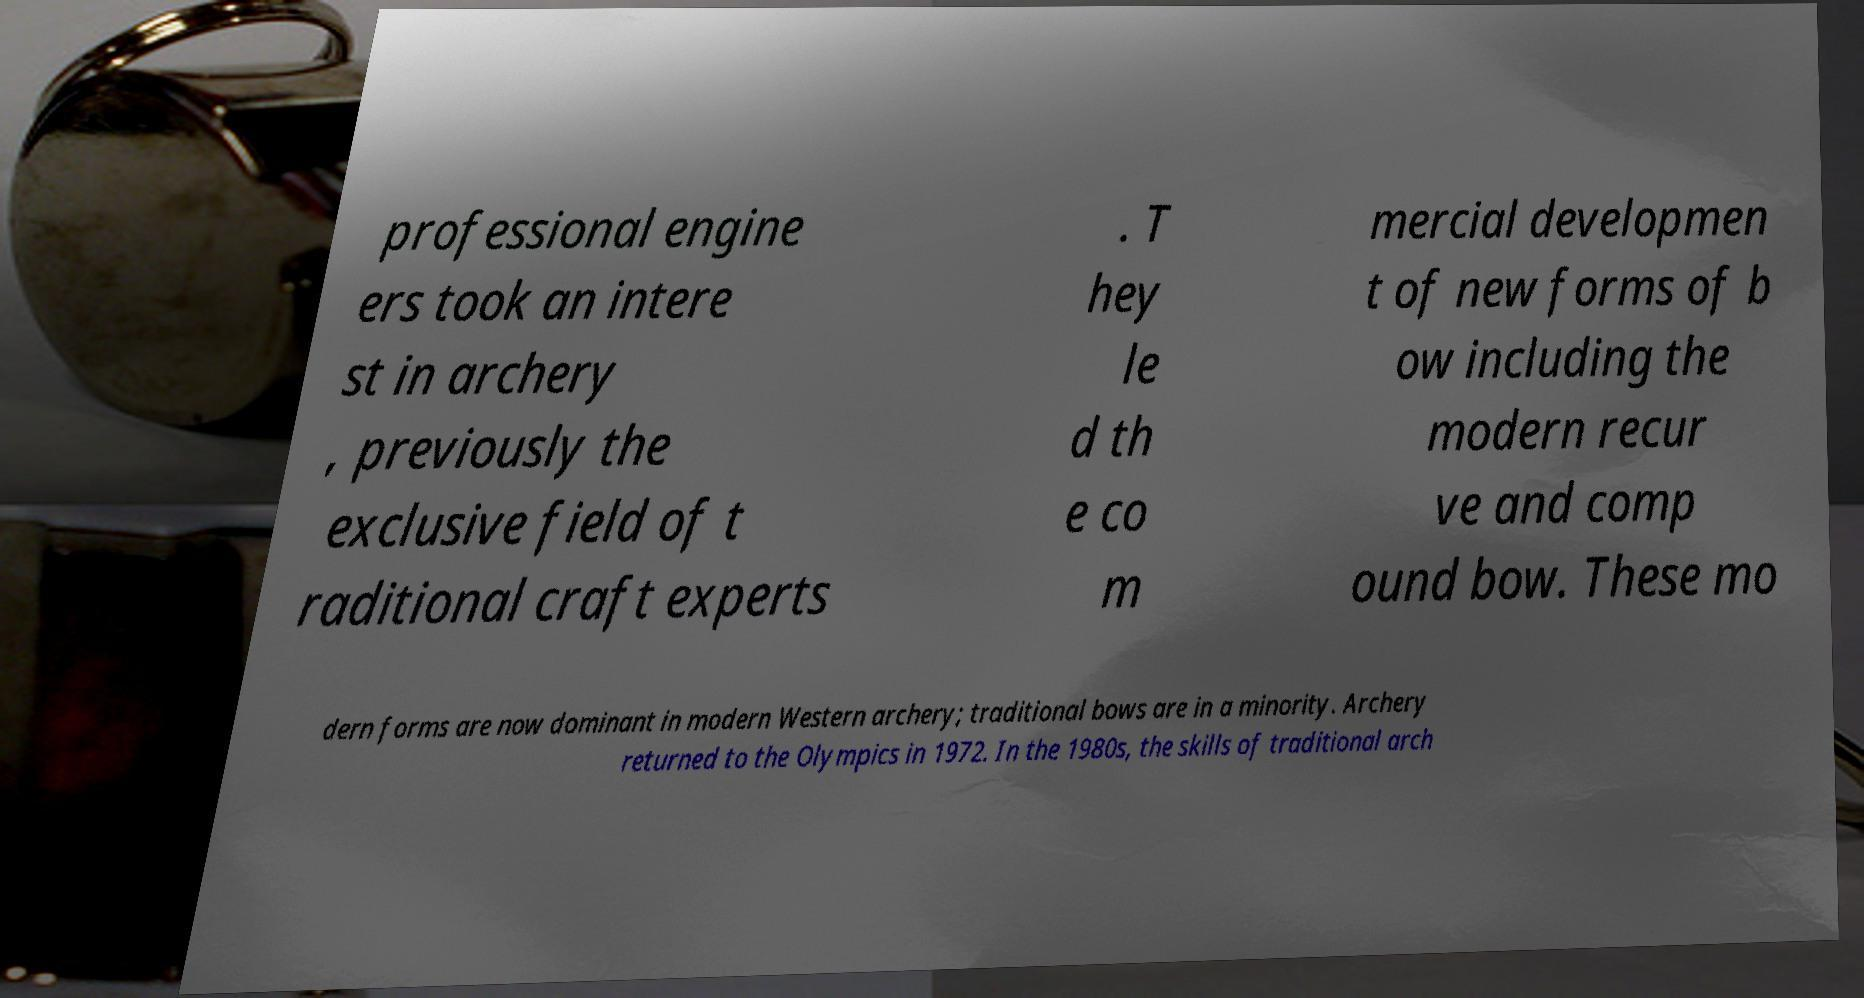I need the written content from this picture converted into text. Can you do that? professional engine ers took an intere st in archery , previously the exclusive field of t raditional craft experts . T hey le d th e co m mercial developmen t of new forms of b ow including the modern recur ve and comp ound bow. These mo dern forms are now dominant in modern Western archery; traditional bows are in a minority. Archery returned to the Olympics in 1972. In the 1980s, the skills of traditional arch 